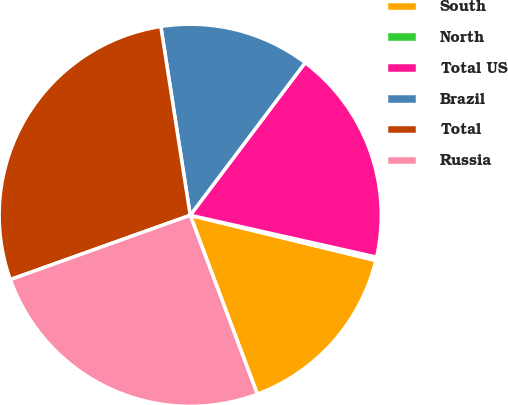Convert chart to OTSL. <chart><loc_0><loc_0><loc_500><loc_500><pie_chart><fcel>South<fcel>North<fcel>Total US<fcel>Brazil<fcel>Total<fcel>Russia<nl><fcel>15.48%<fcel>0.29%<fcel>18.24%<fcel>12.73%<fcel>28.01%<fcel>25.25%<nl></chart> 